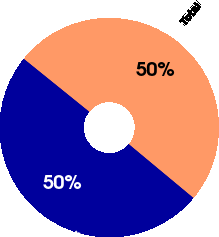Convert chart to OTSL. <chart><loc_0><loc_0><loc_500><loc_500><pie_chart><fcel>Employee termination benefits<fcel>Total<nl><fcel>49.77%<fcel>50.23%<nl></chart> 